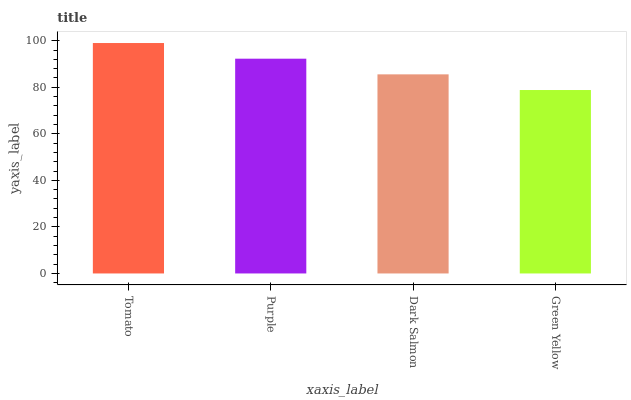Is Green Yellow the minimum?
Answer yes or no. Yes. Is Tomato the maximum?
Answer yes or no. Yes. Is Purple the minimum?
Answer yes or no. No. Is Purple the maximum?
Answer yes or no. No. Is Tomato greater than Purple?
Answer yes or no. Yes. Is Purple less than Tomato?
Answer yes or no. Yes. Is Purple greater than Tomato?
Answer yes or no. No. Is Tomato less than Purple?
Answer yes or no. No. Is Purple the high median?
Answer yes or no. Yes. Is Dark Salmon the low median?
Answer yes or no. Yes. Is Green Yellow the high median?
Answer yes or no. No. Is Tomato the low median?
Answer yes or no. No. 